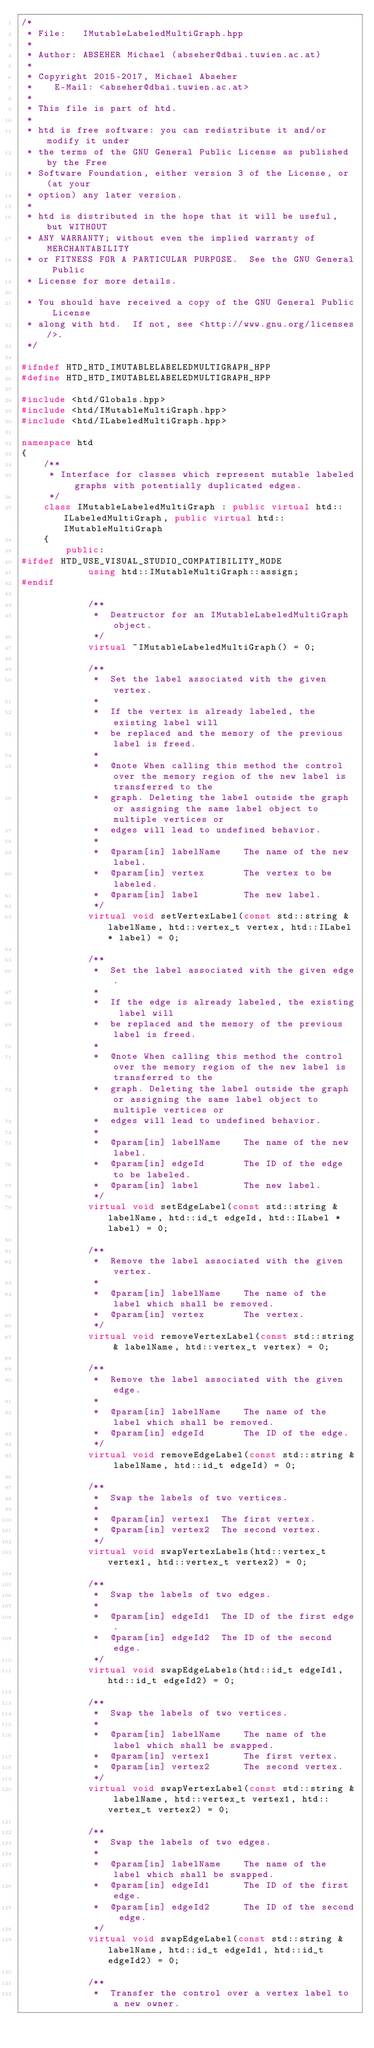Convert code to text. <code><loc_0><loc_0><loc_500><loc_500><_C++_>/* 
 * File:   IMutableLabeledMultiGraph.hpp
 *
 * Author: ABSEHER Michael (abseher@dbai.tuwien.ac.at)
 * 
 * Copyright 2015-2017, Michael Abseher
 *    E-Mail: <abseher@dbai.tuwien.ac.at>
 * 
 * This file is part of htd.
 * 
 * htd is free software: you can redistribute it and/or modify it under 
 * the terms of the GNU General Public License as published by the Free 
 * Software Foundation, either version 3 of the License, or (at your 
 * option) any later version.
 * 
 * htd is distributed in the hope that it will be useful, but WITHOUT 
 * ANY WARRANTY; without even the implied warranty of MERCHANTABILITY 
 * or FITNESS FOR A PARTICULAR PURPOSE.  See the GNU General Public 
 * License for more details.

 * You should have received a copy of the GNU General Public License
 * along with htd.  If not, see <http://www.gnu.org/licenses/>.
 */

#ifndef HTD_HTD_IMUTABLELABELEDMULTIGRAPH_HPP
#define HTD_HTD_IMUTABLELABELEDMULTIGRAPH_HPP

#include <htd/Globals.hpp>
#include <htd/IMutableMultiGraph.hpp>
#include <htd/ILabeledMultiGraph.hpp>

namespace htd
{
    /**
     * Interface for classes which represent mutable labeled graphs with potentially duplicated edges.
     */
    class IMutableLabeledMultiGraph : public virtual htd::ILabeledMultiGraph, public virtual htd::IMutableMultiGraph
    {
        public:
#ifdef HTD_USE_VISUAL_STUDIO_COMPATIBILITY_MODE
            using htd::IMutableMultiGraph::assign;
#endif

            /**
             *  Destructor for an IMutableLabeledMultiGraph object.
             */
            virtual ~IMutableLabeledMultiGraph() = 0;

            /**
             *  Set the label associated with the given vertex.
             *
             *  If the vertex is already labeled, the existing label will
             *  be replaced and the memory of the previous label is freed.
             *
             *  @note When calling this method the control over the memory region of the new label is transferred to the
             *  graph. Deleting the label outside the graph or assigning the same label object to multiple vertices or
             *  edges will lead to undefined behavior.
             *
             *  @param[in] labelName    The name of the new label.
             *  @param[in] vertex       The vertex to be labeled.
             *  @param[in] label        The new label.
             */
            virtual void setVertexLabel(const std::string & labelName, htd::vertex_t vertex, htd::ILabel * label) = 0;

            /**
             *  Set the label associated with the given edge.
             *
             *  If the edge is already labeled, the existing label will
             *  be replaced and the memory of the previous label is freed.
             *
             *  @note When calling this method the control over the memory region of the new label is transferred to the
             *  graph. Deleting the label outside the graph or assigning the same label object to multiple vertices or
             *  edges will lead to undefined behavior.
             *
             *  @param[in] labelName    The name of the new label.
             *  @param[in] edgeId       The ID of the edge to be labeled.
             *  @param[in] label        The new label.
             */
            virtual void setEdgeLabel(const std::string & labelName, htd::id_t edgeId, htd::ILabel * label) = 0;

            /**
             *  Remove the label associated with the given vertex.
             *
             *  @param[in] labelName    The name of the label which shall be removed.
             *  @param[in] vertex       The vertex.
             */
            virtual void removeVertexLabel(const std::string & labelName, htd::vertex_t vertex) = 0;

            /**
             *  Remove the label associated with the given edge.
             *
             *  @param[in] labelName    The name of the label which shall be removed.
             *  @param[in] edgeId       The ID of the edge.
             */
            virtual void removeEdgeLabel(const std::string & labelName, htd::id_t edgeId) = 0;

            /**
             *  Swap the labels of two vertices.
             *
             *  @param[in] vertex1  The first vertex.
             *  @param[in] vertex2  The second vertex.
             */
            virtual void swapVertexLabels(htd::vertex_t vertex1, htd::vertex_t vertex2) = 0;

            /**
             *  Swap the labels of two edges.
             *
             *  @param[in] edgeId1  The ID of the first edge.
             *  @param[in] edgeId2  The ID of the second edge.
             */
            virtual void swapEdgeLabels(htd::id_t edgeId1, htd::id_t edgeId2) = 0;

            /**
             *  Swap the labels of two vertices.
             *
             *  @param[in] labelName    The name of the label which shall be swapped.
             *  @param[in] vertex1      The first vertex.
             *  @param[in] vertex2      The second vertex.
             */
            virtual void swapVertexLabel(const std::string & labelName, htd::vertex_t vertex1, htd::vertex_t vertex2) = 0;

            /**
             *  Swap the labels of two edges.
             *
             *  @param[in] labelName    The name of the label which shall be swapped.
             *  @param[in] edgeId1      The ID of the first edge.
             *  @param[in] edgeId2      The ID of the second edge.
             */
            virtual void swapEdgeLabel(const std::string & labelName, htd::id_t edgeId1, htd::id_t edgeId2) = 0;

            /**
             *  Transfer the control over a vertex label to a new owner.</code> 